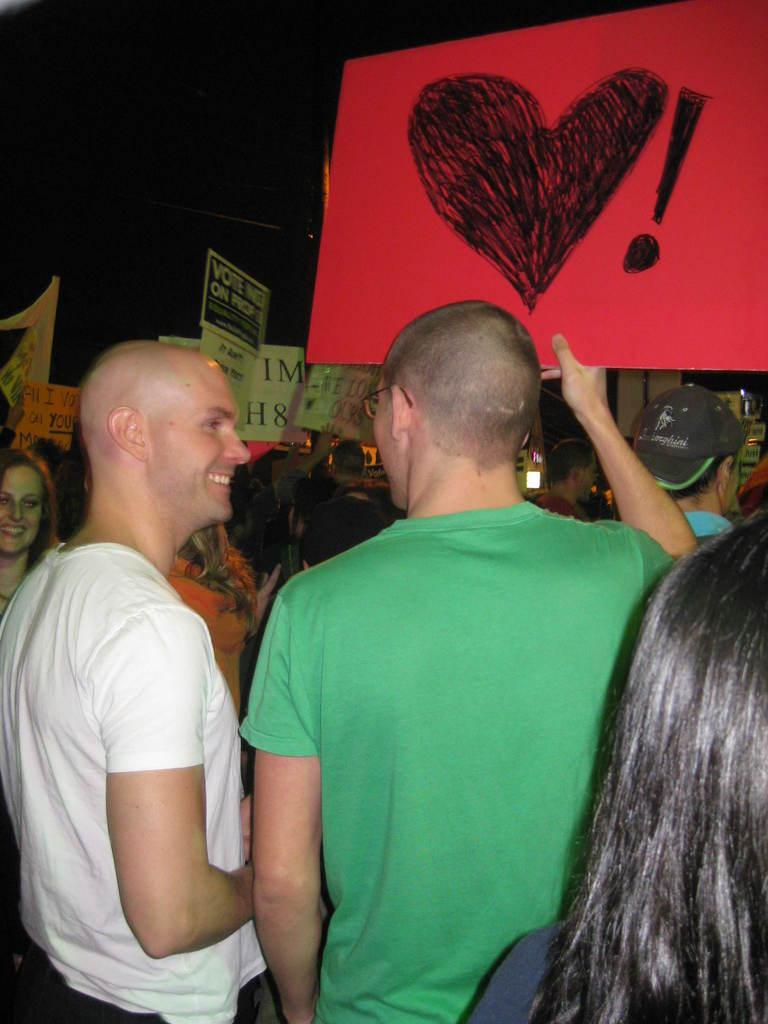How many men are in the image? There are two men in the image. What are the two men holding? The two men are holding a red heart board. What can be seen in the background of the image? There is a group of people in the background of the image. What are the people in the background holding? The people in the background are holding poster boards. What type of unit is the daughter using to measure the zipper in the image? There is no daughter or zipper present in the image. 